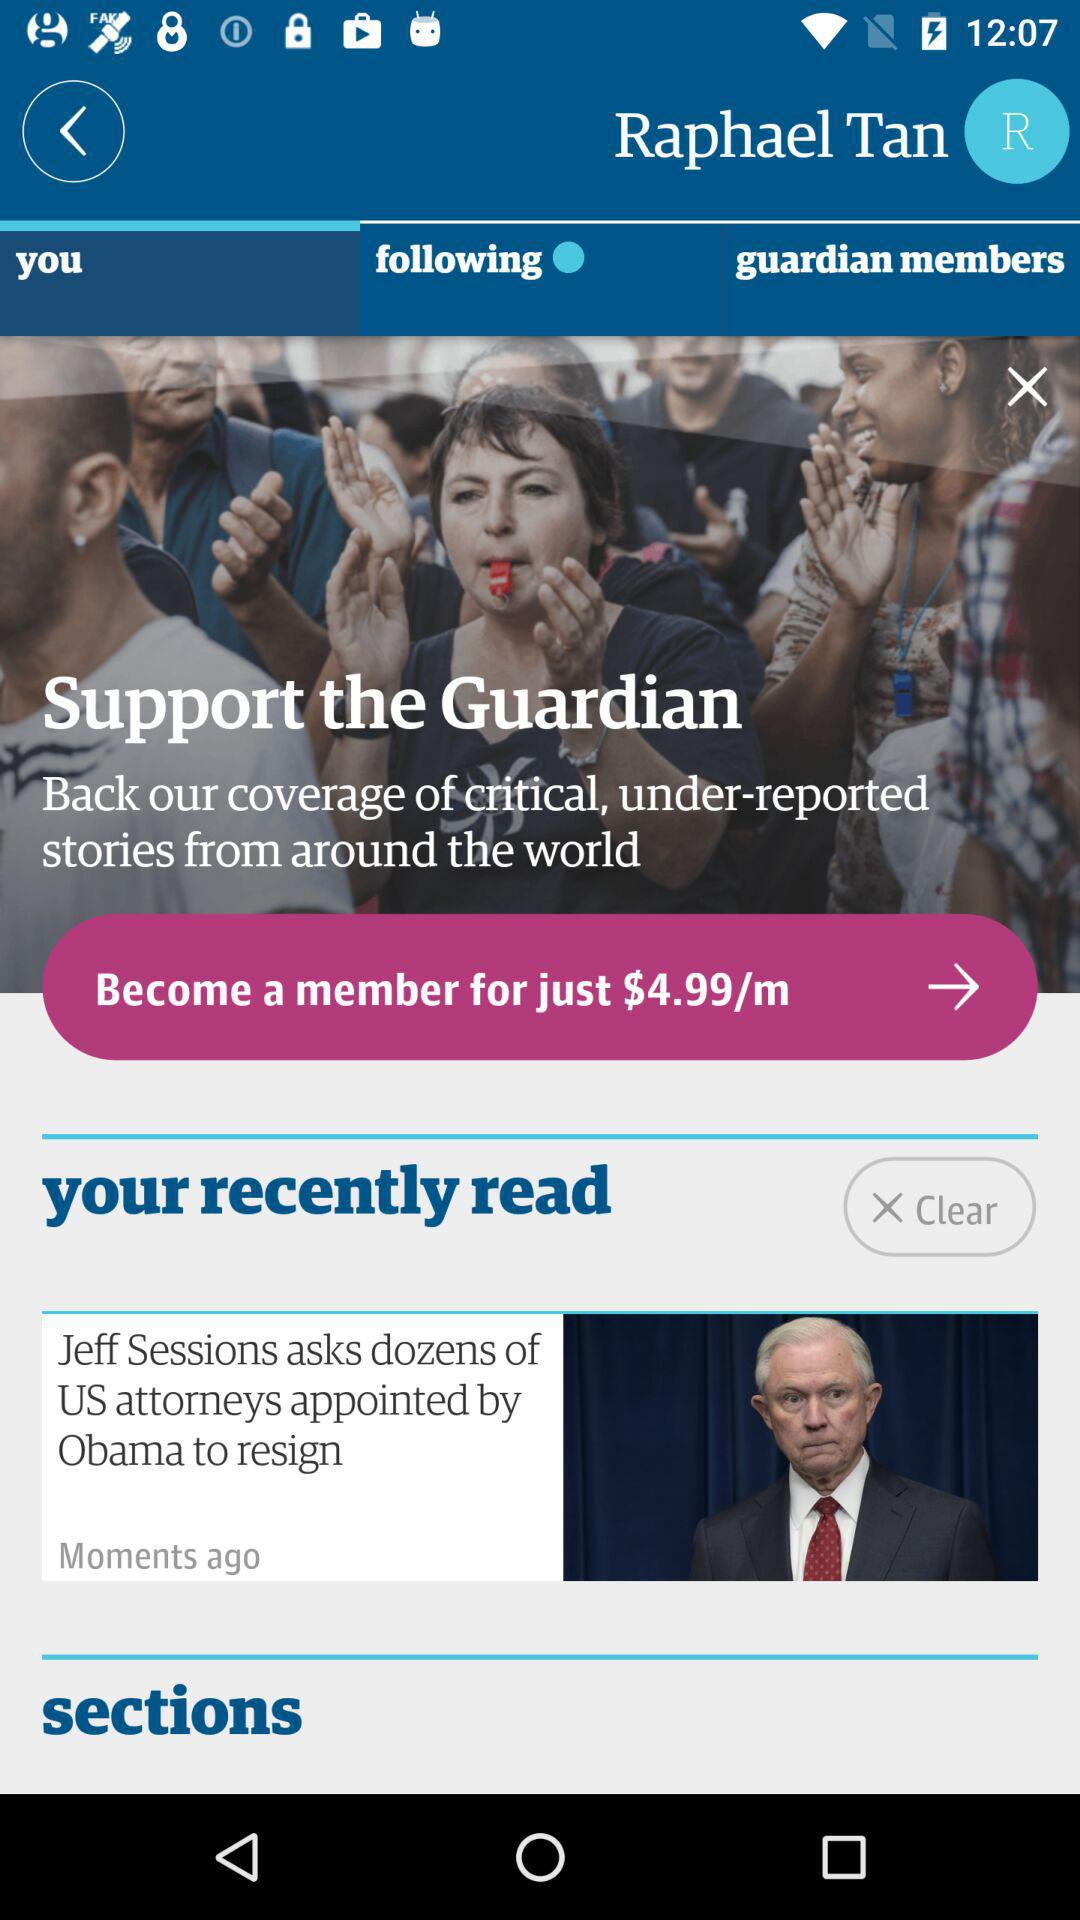What tab has been selected? The selected tab is "you". 